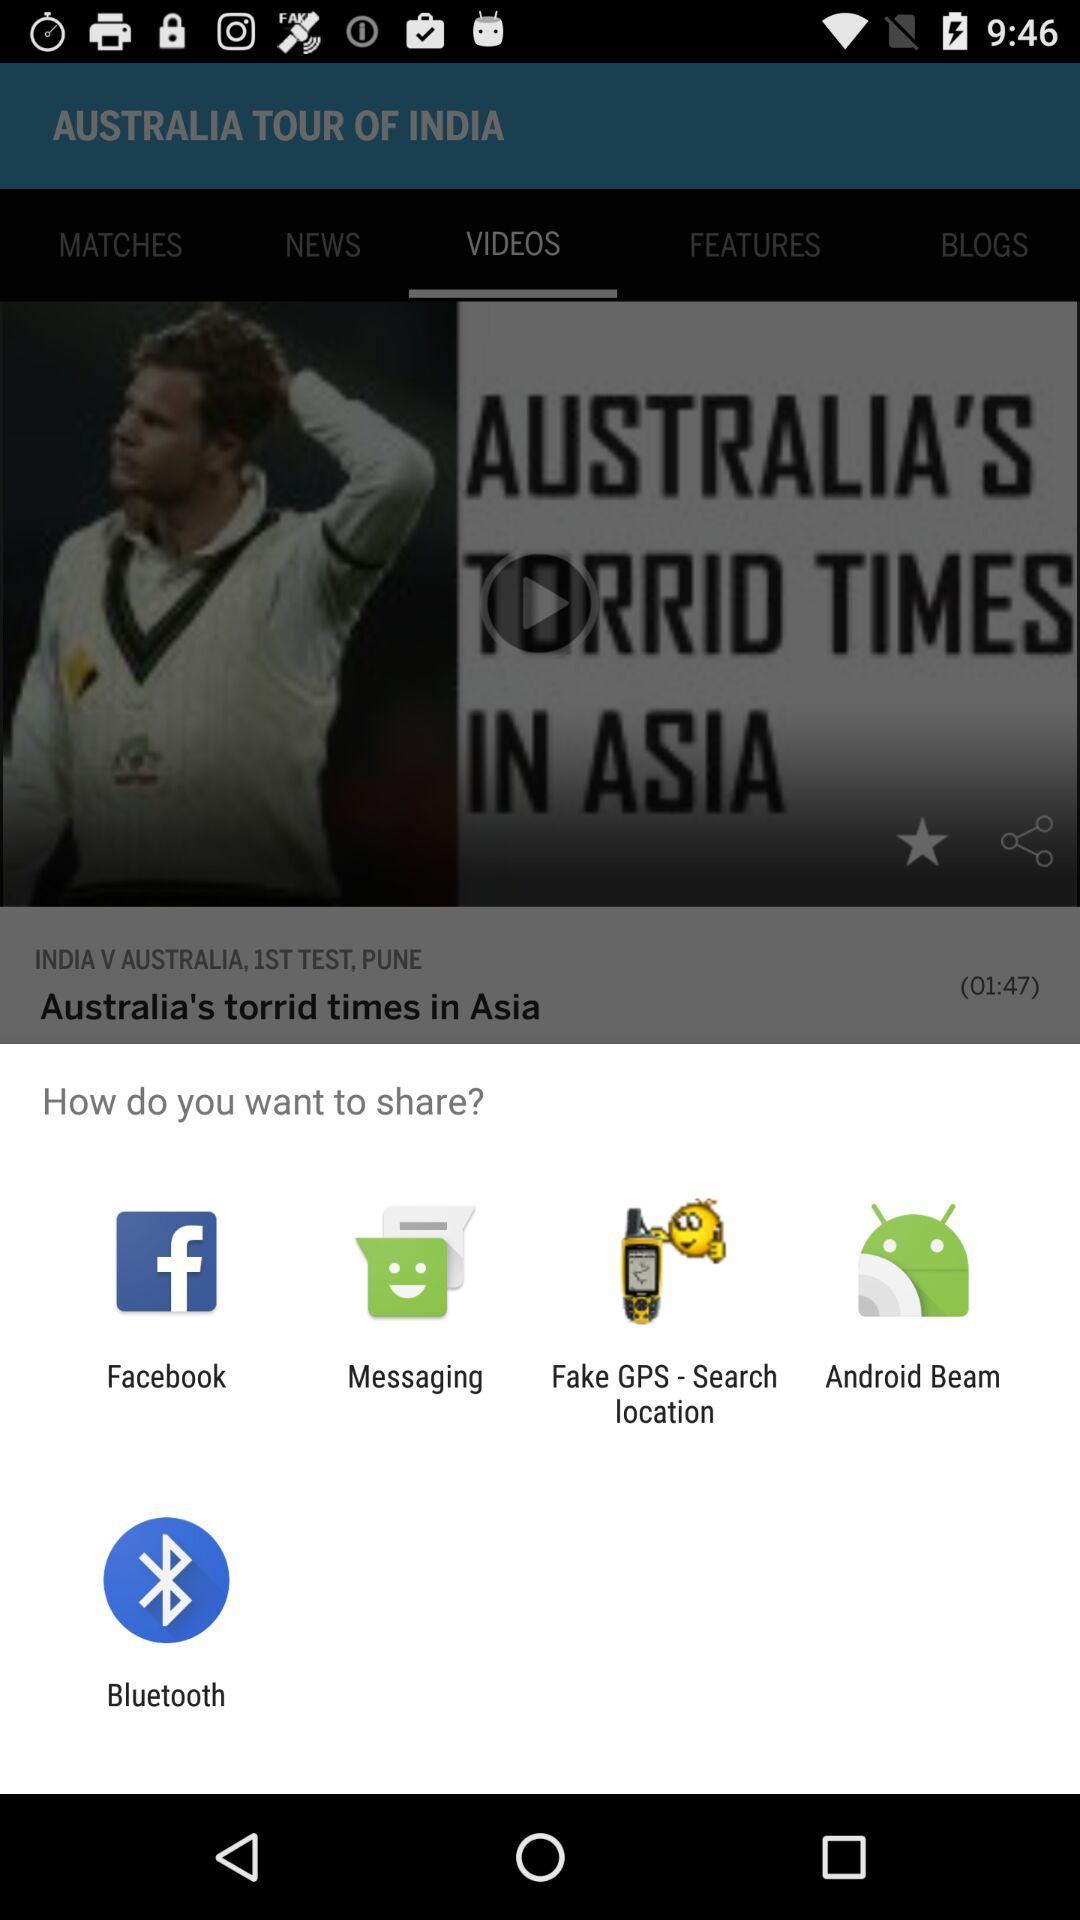What options are given for sharing? The options given for sharing are "Facebook", "Messaging", "Fake GPS - Search location", "Android Beam" and "Bluetooth". 